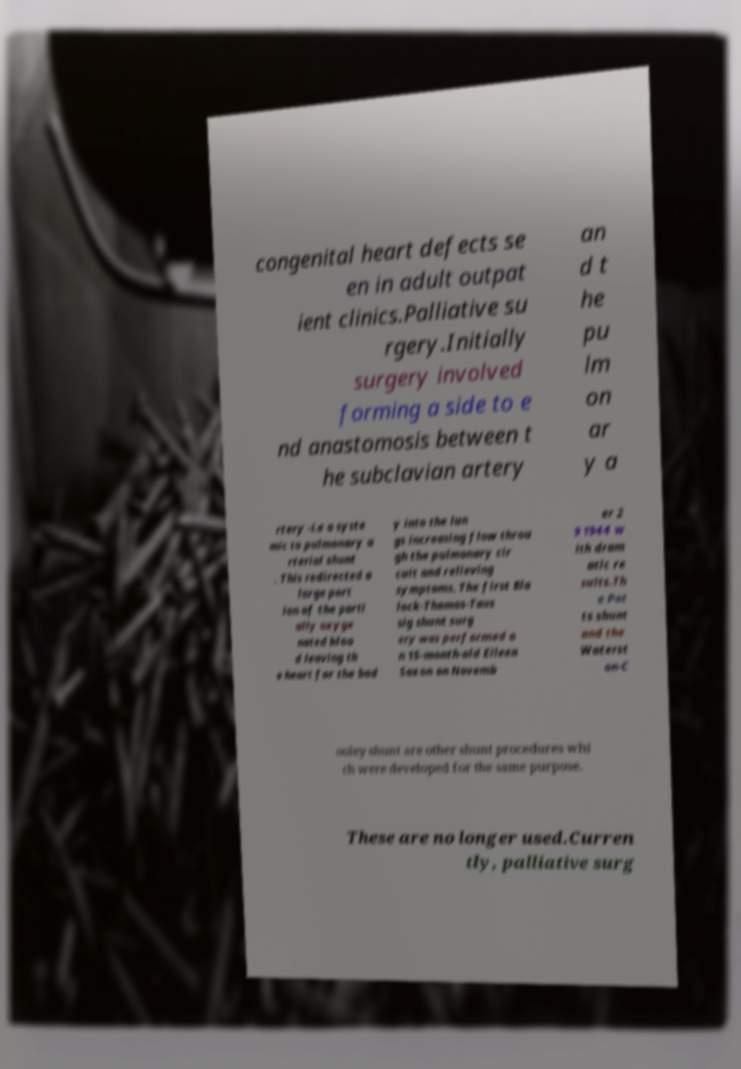Can you accurately transcribe the text from the provided image for me? congenital heart defects se en in adult outpat ient clinics.Palliative su rgery.Initially surgery involved forming a side to e nd anastomosis between t he subclavian artery an d t he pu lm on ar y a rtery -i.e a syste mic to pulmonary a rterial shunt . This redirected a large port ion of the parti ally oxyge nated bloo d leaving th e heart for the bod y into the lun gs increasing flow throu gh the pulmonary cir cuit and relieving symptoms. The first Bla lock-Thomas-Taus sig shunt surg ery was performed o n 15-month-old Eileen Saxon on Novemb er 2 9 1944 w ith dram atic re sults.Th e Pot ts shunt and the Waterst on-C ooley shunt are other shunt procedures whi ch were developed for the same purpose. These are no longer used.Curren tly, palliative surg 